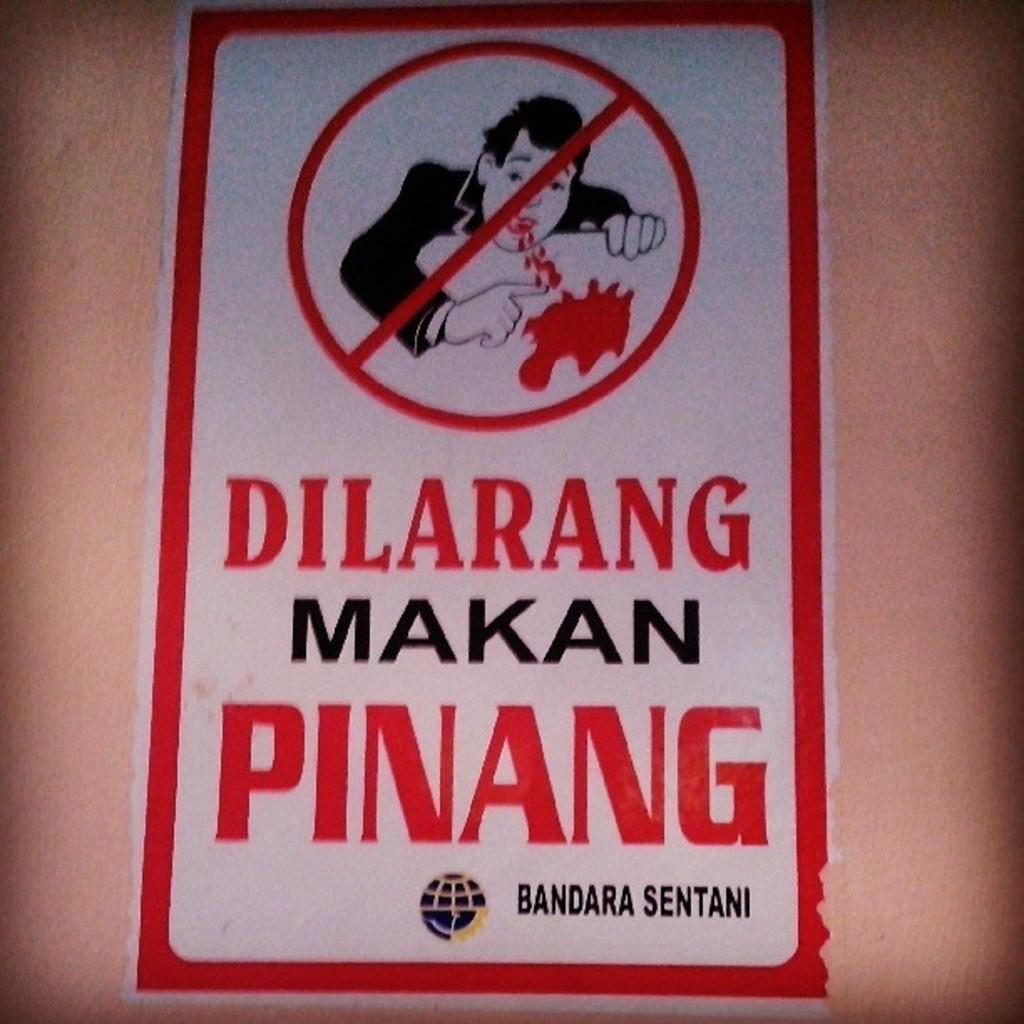What is present on the wall in the image? There is a poster on the wall in the image. How is the poster attached to the wall? The poster is attached to the wall. What is the color of the wall? The wall is in brown color. What is depicted on the poster? There is a person's image on the poster. What else can be seen on the poster besides the image? There is text written on the poster. What type of cream is being advertised on the poster? There is no cream being advertised on the poster; it features a person's image and text. How many legs can be seen on the person in the poster? There is no person with legs visible in the image, as it only shows a poster with a person's image and text. 